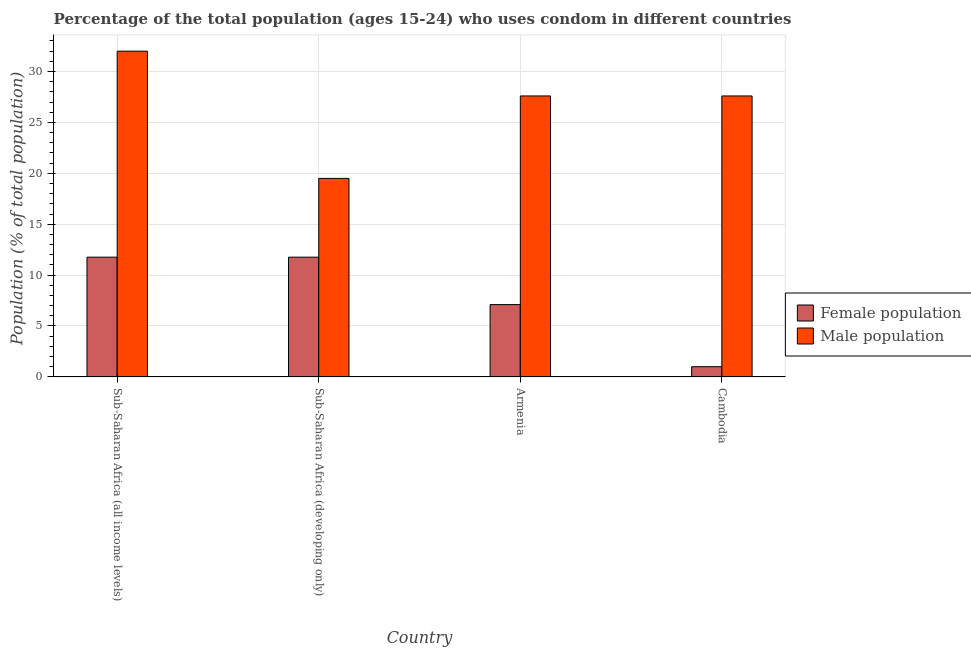How many different coloured bars are there?
Make the answer very short. 2. How many groups of bars are there?
Your answer should be very brief. 4. Are the number of bars on each tick of the X-axis equal?
Provide a short and direct response. Yes. How many bars are there on the 2nd tick from the left?
Provide a succinct answer. 2. How many bars are there on the 3rd tick from the right?
Provide a succinct answer. 2. What is the label of the 4th group of bars from the left?
Your answer should be very brief. Cambodia. In how many cases, is the number of bars for a given country not equal to the number of legend labels?
Ensure brevity in your answer.  0. What is the female population in Sub-Saharan Africa (developing only)?
Your answer should be compact. 11.76. In which country was the male population maximum?
Keep it short and to the point. Sub-Saharan Africa (all income levels). In which country was the male population minimum?
Make the answer very short. Sub-Saharan Africa (developing only). What is the total female population in the graph?
Your response must be concise. 31.62. What is the difference between the female population in Sub-Saharan Africa (all income levels) and that in Sub-Saharan Africa (developing only)?
Your answer should be compact. 0. What is the average female population per country?
Your answer should be compact. 7.91. What is the difference between the male population and female population in Cambodia?
Offer a very short reply. 26.6. What is the ratio of the male population in Sub-Saharan Africa (all income levels) to that in Sub-Saharan Africa (developing only)?
Provide a succinct answer. 1.64. Is the difference between the male population in Sub-Saharan Africa (all income levels) and Sub-Saharan Africa (developing only) greater than the difference between the female population in Sub-Saharan Africa (all income levels) and Sub-Saharan Africa (developing only)?
Your answer should be very brief. Yes. What is the difference between the highest and the second highest female population?
Make the answer very short. 0. What is the difference between the highest and the lowest female population?
Offer a very short reply. 10.76. What does the 2nd bar from the left in Sub-Saharan Africa (developing only) represents?
Provide a short and direct response. Male population. What does the 1st bar from the right in Sub-Saharan Africa (developing only) represents?
Give a very brief answer. Male population. How many bars are there?
Give a very brief answer. 8. How many countries are there in the graph?
Offer a terse response. 4. What is the difference between two consecutive major ticks on the Y-axis?
Your answer should be very brief. 5. Are the values on the major ticks of Y-axis written in scientific E-notation?
Provide a short and direct response. No. Does the graph contain any zero values?
Provide a succinct answer. No. Where does the legend appear in the graph?
Your response must be concise. Center right. What is the title of the graph?
Your answer should be very brief. Percentage of the total population (ages 15-24) who uses condom in different countries. Does "Transport services" appear as one of the legend labels in the graph?
Make the answer very short. No. What is the label or title of the X-axis?
Provide a short and direct response. Country. What is the label or title of the Y-axis?
Ensure brevity in your answer.  Population (% of total population) . What is the Population (% of total population)  in Female population in Sub-Saharan Africa (all income levels)?
Offer a very short reply. 11.76. What is the Population (% of total population)  in Male population in Sub-Saharan Africa (all income levels)?
Ensure brevity in your answer.  32. What is the Population (% of total population)  of Female population in Sub-Saharan Africa (developing only)?
Provide a succinct answer. 11.76. What is the Population (% of total population)  of Male population in Sub-Saharan Africa (developing only)?
Make the answer very short. 19.5. What is the Population (% of total population)  in Male population in Armenia?
Offer a terse response. 27.6. What is the Population (% of total population)  in Female population in Cambodia?
Keep it short and to the point. 1. What is the Population (% of total population)  of Male population in Cambodia?
Keep it short and to the point. 27.6. Across all countries, what is the maximum Population (% of total population)  in Female population?
Ensure brevity in your answer.  11.76. Across all countries, what is the maximum Population (% of total population)  of Male population?
Your answer should be very brief. 32. Across all countries, what is the minimum Population (% of total population)  of Female population?
Provide a succinct answer. 1. Across all countries, what is the minimum Population (% of total population)  in Male population?
Give a very brief answer. 19.5. What is the total Population (% of total population)  in Female population in the graph?
Provide a succinct answer. 31.62. What is the total Population (% of total population)  of Male population in the graph?
Your answer should be compact. 106.7. What is the difference between the Population (% of total population)  in Female population in Sub-Saharan Africa (all income levels) and that in Sub-Saharan Africa (developing only)?
Ensure brevity in your answer.  0. What is the difference between the Population (% of total population)  in Male population in Sub-Saharan Africa (all income levels) and that in Sub-Saharan Africa (developing only)?
Ensure brevity in your answer.  12.5. What is the difference between the Population (% of total population)  in Female population in Sub-Saharan Africa (all income levels) and that in Armenia?
Provide a succinct answer. 4.66. What is the difference between the Population (% of total population)  in Male population in Sub-Saharan Africa (all income levels) and that in Armenia?
Offer a very short reply. 4.4. What is the difference between the Population (% of total population)  of Female population in Sub-Saharan Africa (all income levels) and that in Cambodia?
Provide a succinct answer. 10.76. What is the difference between the Population (% of total population)  of Male population in Sub-Saharan Africa (all income levels) and that in Cambodia?
Your response must be concise. 4.4. What is the difference between the Population (% of total population)  in Female population in Sub-Saharan Africa (developing only) and that in Armenia?
Offer a very short reply. 4.66. What is the difference between the Population (% of total population)  of Female population in Sub-Saharan Africa (developing only) and that in Cambodia?
Your answer should be compact. 10.76. What is the difference between the Population (% of total population)  of Female population in Armenia and that in Cambodia?
Give a very brief answer. 6.1. What is the difference between the Population (% of total population)  in Male population in Armenia and that in Cambodia?
Offer a terse response. 0. What is the difference between the Population (% of total population)  in Female population in Sub-Saharan Africa (all income levels) and the Population (% of total population)  in Male population in Sub-Saharan Africa (developing only)?
Your answer should be very brief. -7.74. What is the difference between the Population (% of total population)  of Female population in Sub-Saharan Africa (all income levels) and the Population (% of total population)  of Male population in Armenia?
Give a very brief answer. -15.84. What is the difference between the Population (% of total population)  in Female population in Sub-Saharan Africa (all income levels) and the Population (% of total population)  in Male population in Cambodia?
Offer a very short reply. -15.84. What is the difference between the Population (% of total population)  in Female population in Sub-Saharan Africa (developing only) and the Population (% of total population)  in Male population in Armenia?
Give a very brief answer. -15.84. What is the difference between the Population (% of total population)  of Female population in Sub-Saharan Africa (developing only) and the Population (% of total population)  of Male population in Cambodia?
Make the answer very short. -15.84. What is the difference between the Population (% of total population)  of Female population in Armenia and the Population (% of total population)  of Male population in Cambodia?
Your answer should be very brief. -20.5. What is the average Population (% of total population)  of Female population per country?
Give a very brief answer. 7.91. What is the average Population (% of total population)  of Male population per country?
Give a very brief answer. 26.68. What is the difference between the Population (% of total population)  in Female population and Population (% of total population)  in Male population in Sub-Saharan Africa (all income levels)?
Give a very brief answer. -20.24. What is the difference between the Population (% of total population)  in Female population and Population (% of total population)  in Male population in Sub-Saharan Africa (developing only)?
Make the answer very short. -7.74. What is the difference between the Population (% of total population)  in Female population and Population (% of total population)  in Male population in Armenia?
Offer a very short reply. -20.5. What is the difference between the Population (% of total population)  of Female population and Population (% of total population)  of Male population in Cambodia?
Your answer should be very brief. -26.6. What is the ratio of the Population (% of total population)  of Female population in Sub-Saharan Africa (all income levels) to that in Sub-Saharan Africa (developing only)?
Provide a succinct answer. 1. What is the ratio of the Population (% of total population)  in Male population in Sub-Saharan Africa (all income levels) to that in Sub-Saharan Africa (developing only)?
Keep it short and to the point. 1.64. What is the ratio of the Population (% of total population)  in Female population in Sub-Saharan Africa (all income levels) to that in Armenia?
Your answer should be very brief. 1.66. What is the ratio of the Population (% of total population)  of Male population in Sub-Saharan Africa (all income levels) to that in Armenia?
Give a very brief answer. 1.16. What is the ratio of the Population (% of total population)  in Female population in Sub-Saharan Africa (all income levels) to that in Cambodia?
Offer a very short reply. 11.76. What is the ratio of the Population (% of total population)  in Male population in Sub-Saharan Africa (all income levels) to that in Cambodia?
Give a very brief answer. 1.16. What is the ratio of the Population (% of total population)  in Female population in Sub-Saharan Africa (developing only) to that in Armenia?
Provide a short and direct response. 1.66. What is the ratio of the Population (% of total population)  in Male population in Sub-Saharan Africa (developing only) to that in Armenia?
Provide a succinct answer. 0.71. What is the ratio of the Population (% of total population)  of Female population in Sub-Saharan Africa (developing only) to that in Cambodia?
Provide a short and direct response. 11.76. What is the ratio of the Population (% of total population)  in Male population in Sub-Saharan Africa (developing only) to that in Cambodia?
Your answer should be very brief. 0.71. What is the ratio of the Population (% of total population)  of Male population in Armenia to that in Cambodia?
Give a very brief answer. 1. What is the difference between the highest and the second highest Population (% of total population)  in Female population?
Offer a terse response. 0. What is the difference between the highest and the second highest Population (% of total population)  of Male population?
Ensure brevity in your answer.  4.4. What is the difference between the highest and the lowest Population (% of total population)  in Female population?
Keep it short and to the point. 10.76. 